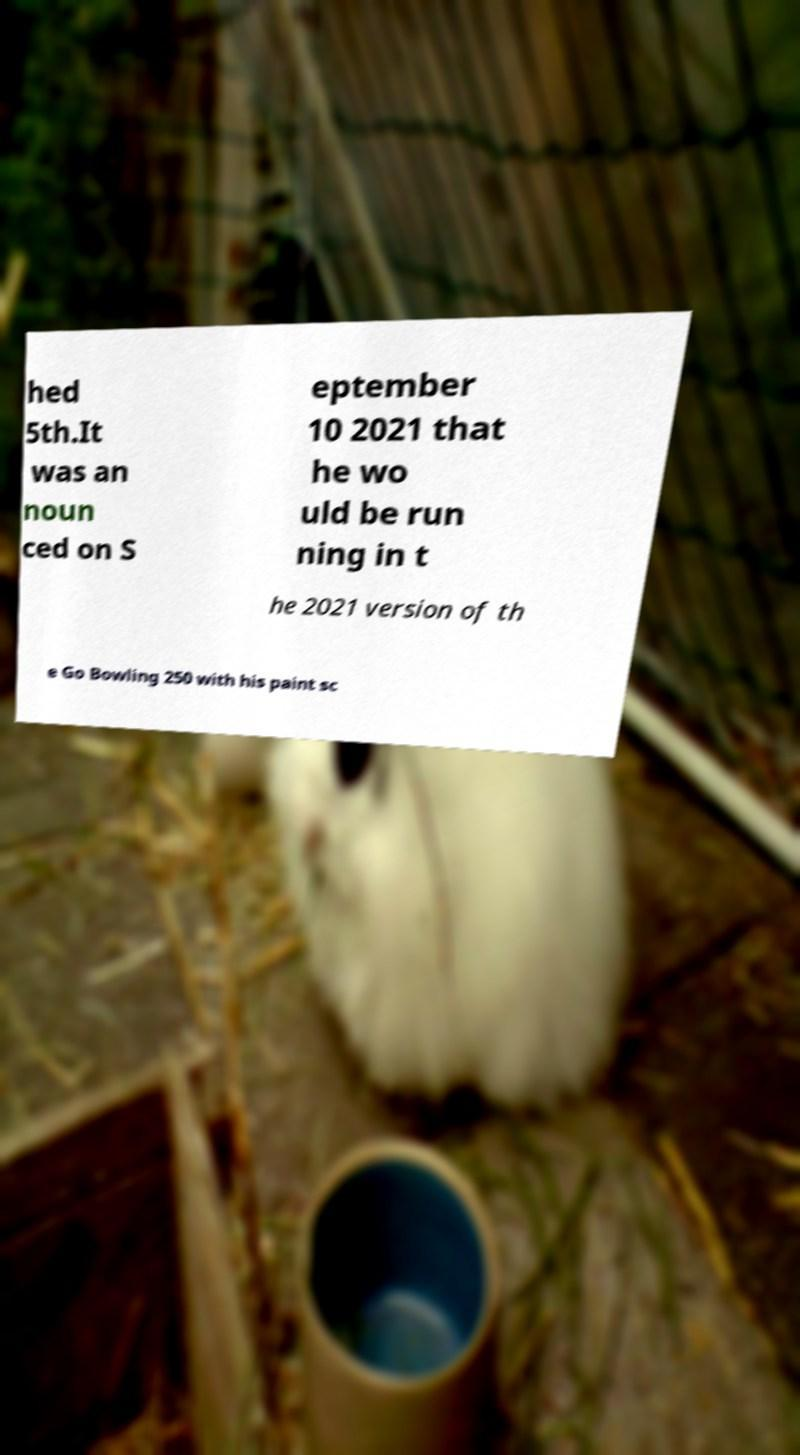What messages or text are displayed in this image? I need them in a readable, typed format. hed 5th.It was an noun ced on S eptember 10 2021 that he wo uld be run ning in t he 2021 version of th e Go Bowling 250 with his paint sc 